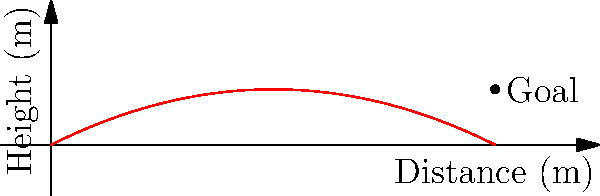In a crucial match against Brazil, Lionel Messi takes a free kick from 20 meters away from the goal. The trajectory of the ball can be modeled by the equation $h(x) = -0.025x^2 + 0.5x$, where $h$ is the height of the ball in meters and $x$ is the horizontal distance from the kicking point in meters. The center of the goal is 2.5 meters high. Will Messi's free kick result in a goal? To determine if Messi's free kick will result in a goal, we need to calculate the height of the ball when it reaches the goal line (20 meters from the kicking point).

1. We have the equation: $h(x) = -0.025x^2 + 0.5x$
2. We need to find $h(20)$, as the goal is 20 meters away:
   $h(20) = -0.025(20)^2 + 0.5(20)$
3. Simplify:
   $h(20) = -0.025(400) + 10$
   $h(20) = -10 + 10 = 0$
4. The ball's height at the goal line is 0 meters.
5. Since the center of the goal is at 2.5 meters, and the ball's height is 0 meters, the free kick will not result in a goal.

This outcome might disappoint our Argentine football fan, as Messi's free kick falls short of the target.
Answer: No, the free kick will not result in a goal. 